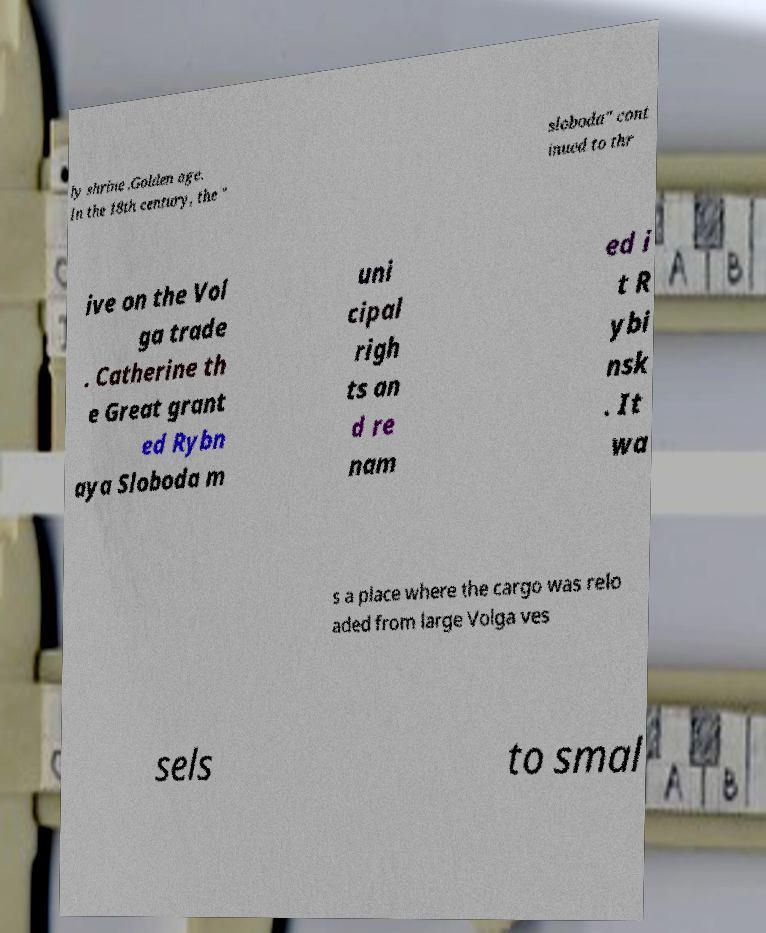There's text embedded in this image that I need extracted. Can you transcribe it verbatim? ly shrine .Golden age. In the 18th century, the " sloboda" cont inued to thr ive on the Vol ga trade . Catherine th e Great grant ed Rybn aya Sloboda m uni cipal righ ts an d re nam ed i t R ybi nsk . It wa s a place where the cargo was relo aded from large Volga ves sels to smal 